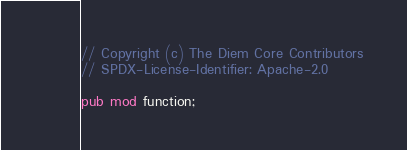Convert code to text. <code><loc_0><loc_0><loc_500><loc_500><_Rust_>// Copyright (c) The Diem Core Contributors
// SPDX-License-Identifier: Apache-2.0

pub mod function;
</code> 